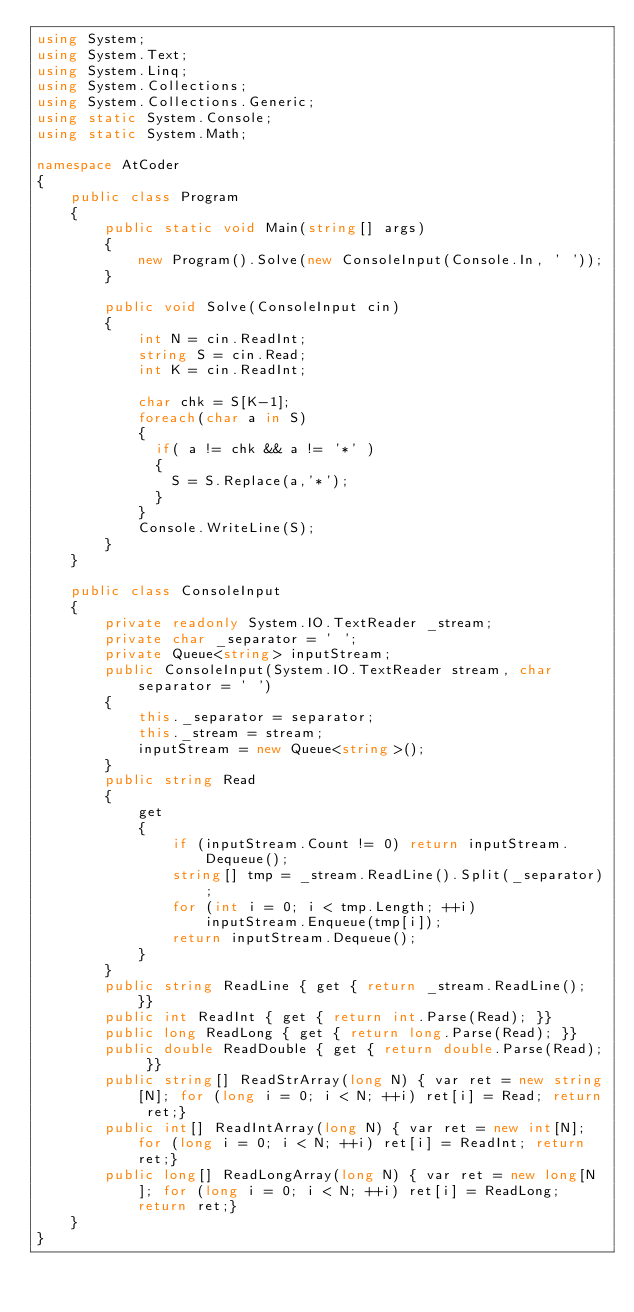<code> <loc_0><loc_0><loc_500><loc_500><_C#_>using System;
using System.Text;
using System.Linq;
using System.Collections;
using System.Collections.Generic;
using static System.Console;
using static System.Math;

namespace AtCoder
{
    public class Program
    {
        public static void Main(string[] args)
        {
            new Program().Solve(new ConsoleInput(Console.In, ' '));
        }

        public void Solve(ConsoleInput cin)
        {
            int N = cin.ReadInt;
            string S = cin.Read;
            int K = cin.ReadInt;
          
            char chk = S[K-1];
            foreach(char a in S)
            {
              if( a != chk && a != '*' )
              {
                S = S.Replace(a,'*');
              }
            }
            Console.WriteLine(S);
        }
    }

    public class ConsoleInput
    {
        private readonly System.IO.TextReader _stream;
        private char _separator = ' ';
        private Queue<string> inputStream;
        public ConsoleInput(System.IO.TextReader stream, char separator = ' ')
        {
            this._separator = separator;
            this._stream = stream;
            inputStream = new Queue<string>();
        }
        public string Read
        {
            get
            {
                if (inputStream.Count != 0) return inputStream.Dequeue();
                string[] tmp = _stream.ReadLine().Split(_separator);
                for (int i = 0; i < tmp.Length; ++i)
                    inputStream.Enqueue(tmp[i]);
                return inputStream.Dequeue();
            }
        }
        public string ReadLine { get { return _stream.ReadLine(); }}
        public int ReadInt { get { return int.Parse(Read); }}
        public long ReadLong { get { return long.Parse(Read); }}
        public double ReadDouble { get { return double.Parse(Read); }}
        public string[] ReadStrArray(long N) { var ret = new string[N]; for (long i = 0; i < N; ++i) ret[i] = Read; return ret;}
        public int[] ReadIntArray(long N) { var ret = new int[N]; for (long i = 0; i < N; ++i) ret[i] = ReadInt; return ret;}
        public long[] ReadLongArray(long N) { var ret = new long[N]; for (long i = 0; i < N; ++i) ret[i] = ReadLong; return ret;}
    }
}</code> 